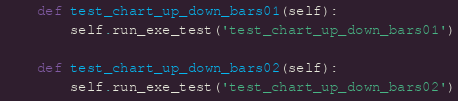Convert code to text. <code><loc_0><loc_0><loc_500><loc_500><_Python_>    def test_chart_up_down_bars01(self):
        self.run_exe_test('test_chart_up_down_bars01')

    def test_chart_up_down_bars02(self):
        self.run_exe_test('test_chart_up_down_bars02')
</code> 